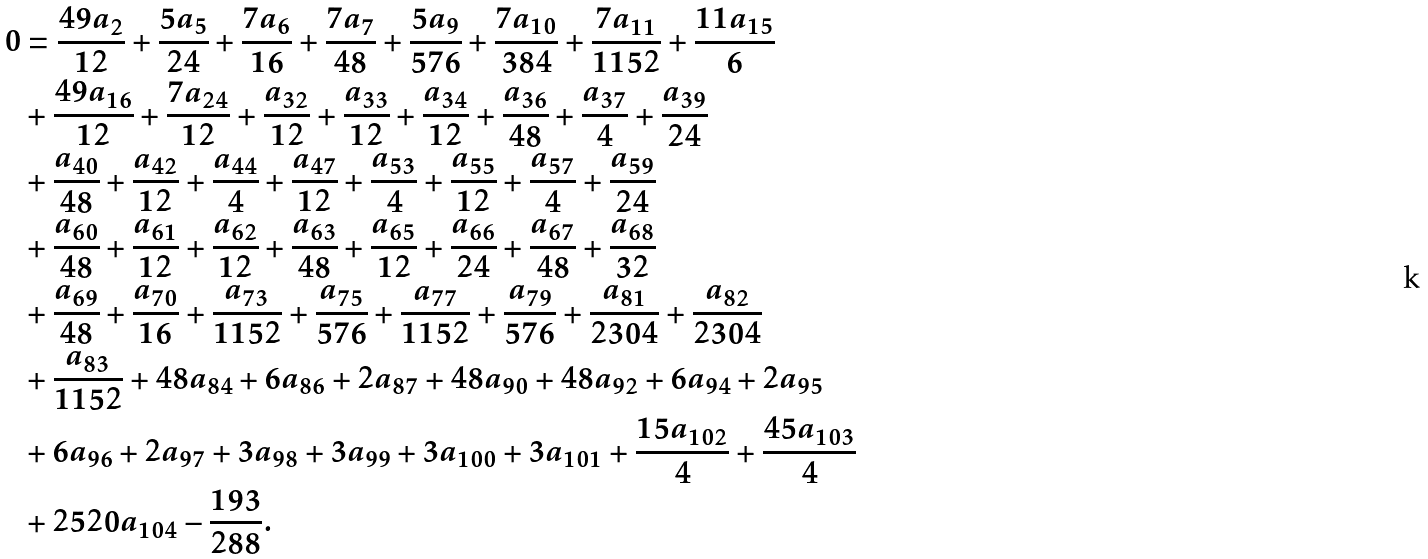<formula> <loc_0><loc_0><loc_500><loc_500>0 & = \frac { 4 9 a _ { 2 } } { 1 2 } + \frac { 5 a _ { 5 } } { 2 4 } + \frac { 7 a _ { 6 } } { 1 6 } + \frac { 7 a _ { 7 } } { 4 8 } + \frac { 5 a _ { 9 } } { 5 7 6 } + \frac { 7 a _ { 1 0 } } { 3 8 4 } + \frac { 7 a _ { 1 1 } } { 1 1 5 2 } + \frac { 1 1 a _ { 1 5 } } { 6 } \\ & + \frac { 4 9 a _ { 1 6 } } { 1 2 } + \frac { 7 a _ { 2 4 } } { 1 2 } + \frac { a _ { 3 2 } } { 1 2 } + \frac { a _ { 3 3 } } { 1 2 } + \frac { a _ { 3 4 } } { 1 2 } + \frac { a _ { 3 6 } } { 4 8 } + \frac { a _ { 3 7 } } { 4 } + \frac { a _ { 3 9 } } { 2 4 } \\ & + \frac { a _ { 4 0 } } { 4 8 } + \frac { a _ { 4 2 } } { 1 2 } + \frac { a _ { 4 4 } } { 4 } + \frac { a _ { 4 7 } } { 1 2 } + \frac { a _ { 5 3 } } { 4 } + \frac { a _ { 5 5 } } { 1 2 } + \frac { a _ { 5 7 } } { 4 } + \frac { a _ { 5 9 } } { 2 4 } \\ & + \frac { a _ { 6 0 } } { 4 8 } + \frac { a _ { 6 1 } } { 1 2 } + \frac { a _ { 6 2 } } { 1 2 } + \frac { a _ { 6 3 } } { 4 8 } + \frac { a _ { 6 5 } } { 1 2 } + \frac { a _ { 6 6 } } { 2 4 } + \frac { a _ { 6 7 } } { 4 8 } + \frac { a _ { 6 8 } } { 3 2 } \\ & + \frac { a _ { 6 9 } } { 4 8 } + \frac { a _ { 7 0 } } { 1 6 } + \frac { a _ { 7 3 } } { 1 1 5 2 } + \frac { a _ { 7 5 } } { 5 7 6 } + \frac { a _ { 7 7 } } { 1 1 5 2 } + \frac { a _ { 7 9 } } { 5 7 6 } + \frac { a _ { 8 1 } } { 2 3 0 4 } + \frac { a _ { 8 2 } } { 2 3 0 4 } \\ & + \frac { a _ { 8 3 } } { 1 1 5 2 } + 4 8 a _ { 8 4 } + 6 a _ { 8 6 } + 2 a _ { 8 7 } + 4 8 a _ { 9 0 } + 4 8 a _ { 9 2 } + 6 a _ { 9 4 } + 2 a _ { 9 5 } \\ & + 6 a _ { 9 6 } + 2 a _ { 9 7 } + 3 a _ { 9 8 } + 3 a _ { 9 9 } + 3 a _ { 1 0 0 } + 3 a _ { 1 0 1 } + \frac { 1 5 a _ { 1 0 2 } } { 4 } + \frac { 4 5 a _ { 1 0 3 } } { 4 } \\ & + 2 5 2 0 a _ { 1 0 4 } - \frac { 1 9 3 } { 2 8 8 } .</formula> 